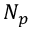Convert formula to latex. <formula><loc_0><loc_0><loc_500><loc_500>N _ { p }</formula> 